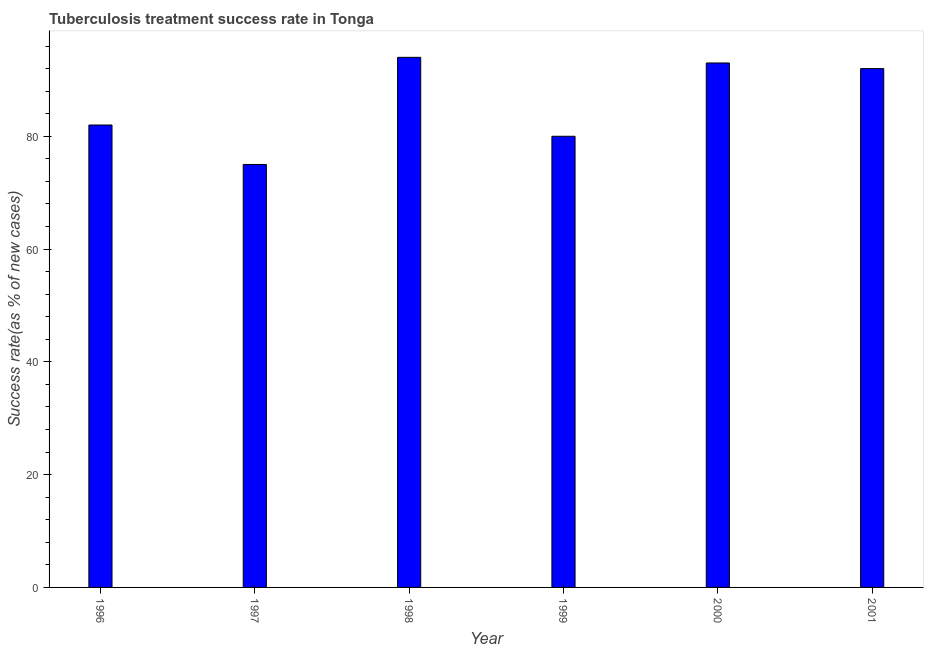Does the graph contain grids?
Your answer should be very brief. No. What is the title of the graph?
Offer a very short reply. Tuberculosis treatment success rate in Tonga. What is the label or title of the X-axis?
Provide a short and direct response. Year. What is the label or title of the Y-axis?
Ensure brevity in your answer.  Success rate(as % of new cases). What is the tuberculosis treatment success rate in 1998?
Offer a very short reply. 94. Across all years, what is the maximum tuberculosis treatment success rate?
Give a very brief answer. 94. Across all years, what is the minimum tuberculosis treatment success rate?
Keep it short and to the point. 75. In which year was the tuberculosis treatment success rate maximum?
Make the answer very short. 1998. In which year was the tuberculosis treatment success rate minimum?
Provide a succinct answer. 1997. What is the sum of the tuberculosis treatment success rate?
Offer a very short reply. 516. What is the median tuberculosis treatment success rate?
Ensure brevity in your answer.  87. In how many years, is the tuberculosis treatment success rate greater than 84 %?
Offer a very short reply. 3. Do a majority of the years between 2001 and 1997 (inclusive) have tuberculosis treatment success rate greater than 36 %?
Provide a succinct answer. Yes. What is the ratio of the tuberculosis treatment success rate in 1996 to that in 2000?
Your response must be concise. 0.88. Is the sum of the tuberculosis treatment success rate in 1998 and 2001 greater than the maximum tuberculosis treatment success rate across all years?
Keep it short and to the point. Yes. In how many years, is the tuberculosis treatment success rate greater than the average tuberculosis treatment success rate taken over all years?
Provide a short and direct response. 3. How many bars are there?
Offer a very short reply. 6. How many years are there in the graph?
Offer a very short reply. 6. What is the Success rate(as % of new cases) in 1996?
Offer a terse response. 82. What is the Success rate(as % of new cases) in 1997?
Ensure brevity in your answer.  75. What is the Success rate(as % of new cases) of 1998?
Provide a short and direct response. 94. What is the Success rate(as % of new cases) in 2000?
Give a very brief answer. 93. What is the Success rate(as % of new cases) of 2001?
Make the answer very short. 92. What is the difference between the Success rate(as % of new cases) in 1996 and 1999?
Provide a succinct answer. 2. What is the difference between the Success rate(as % of new cases) in 1997 and 1998?
Give a very brief answer. -19. What is the difference between the Success rate(as % of new cases) in 1997 and 1999?
Ensure brevity in your answer.  -5. What is the difference between the Success rate(as % of new cases) in 1997 and 2000?
Your answer should be very brief. -18. What is the difference between the Success rate(as % of new cases) in 1997 and 2001?
Your answer should be very brief. -17. What is the difference between the Success rate(as % of new cases) in 1998 and 1999?
Give a very brief answer. 14. What is the difference between the Success rate(as % of new cases) in 1998 and 2000?
Provide a short and direct response. 1. What is the difference between the Success rate(as % of new cases) in 1998 and 2001?
Keep it short and to the point. 2. What is the ratio of the Success rate(as % of new cases) in 1996 to that in 1997?
Ensure brevity in your answer.  1.09. What is the ratio of the Success rate(as % of new cases) in 1996 to that in 1998?
Your answer should be very brief. 0.87. What is the ratio of the Success rate(as % of new cases) in 1996 to that in 2000?
Offer a very short reply. 0.88. What is the ratio of the Success rate(as % of new cases) in 1996 to that in 2001?
Provide a short and direct response. 0.89. What is the ratio of the Success rate(as % of new cases) in 1997 to that in 1998?
Provide a succinct answer. 0.8. What is the ratio of the Success rate(as % of new cases) in 1997 to that in 1999?
Your answer should be compact. 0.94. What is the ratio of the Success rate(as % of new cases) in 1997 to that in 2000?
Make the answer very short. 0.81. What is the ratio of the Success rate(as % of new cases) in 1997 to that in 2001?
Keep it short and to the point. 0.81. What is the ratio of the Success rate(as % of new cases) in 1998 to that in 1999?
Your response must be concise. 1.18. What is the ratio of the Success rate(as % of new cases) in 1999 to that in 2000?
Keep it short and to the point. 0.86. What is the ratio of the Success rate(as % of new cases) in 1999 to that in 2001?
Your answer should be compact. 0.87. 